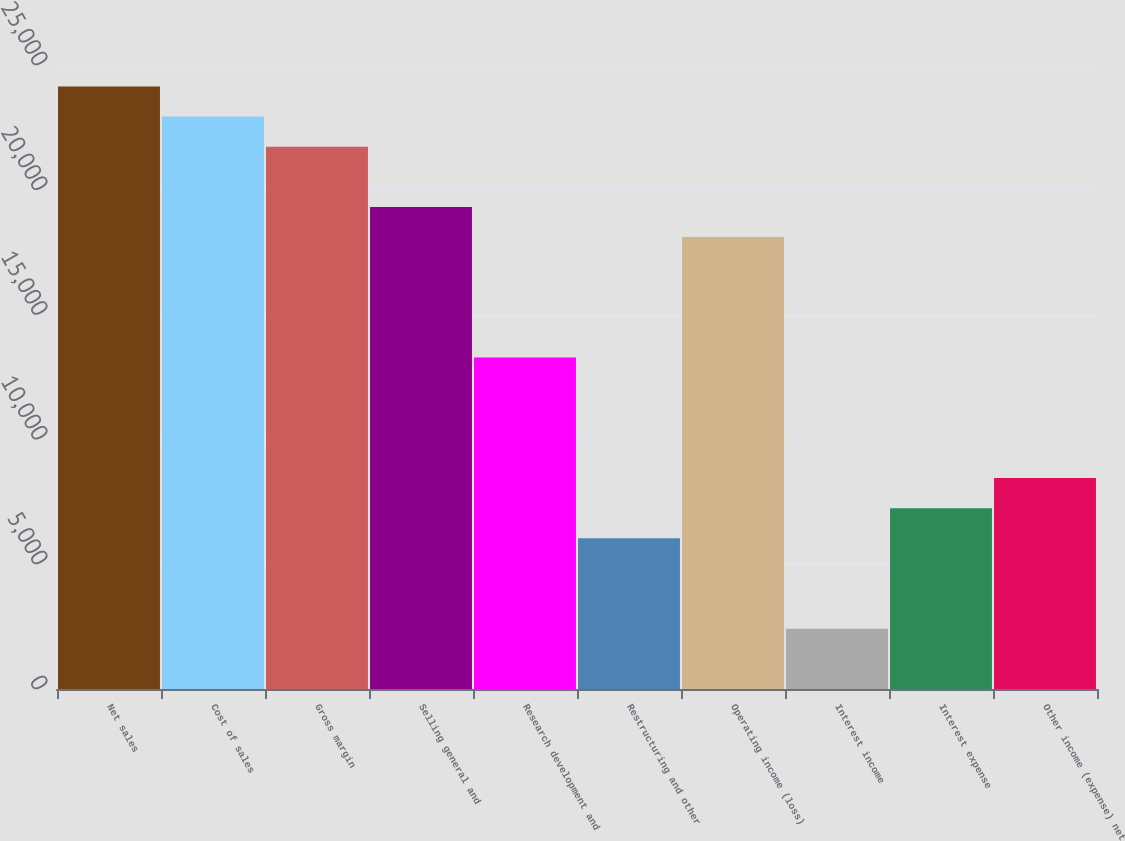Convert chart. <chart><loc_0><loc_0><loc_500><loc_500><bar_chart><fcel>Net sales<fcel>Cost of sales<fcel>Gross margin<fcel>Selling general and<fcel>Research development and<fcel>Restructuring and other<fcel>Operating income (loss)<fcel>Interest income<fcel>Interest expense<fcel>Other income (expense) net<nl><fcel>24139.4<fcel>22932.5<fcel>21725.6<fcel>19311.7<fcel>13277<fcel>6035.34<fcel>18104.7<fcel>2414.52<fcel>7242.28<fcel>8449.22<nl></chart> 